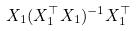<formula> <loc_0><loc_0><loc_500><loc_500>X _ { 1 } ( X _ { 1 } ^ { \top } X _ { 1 } ) ^ { - 1 } X _ { 1 } ^ { \top }</formula> 